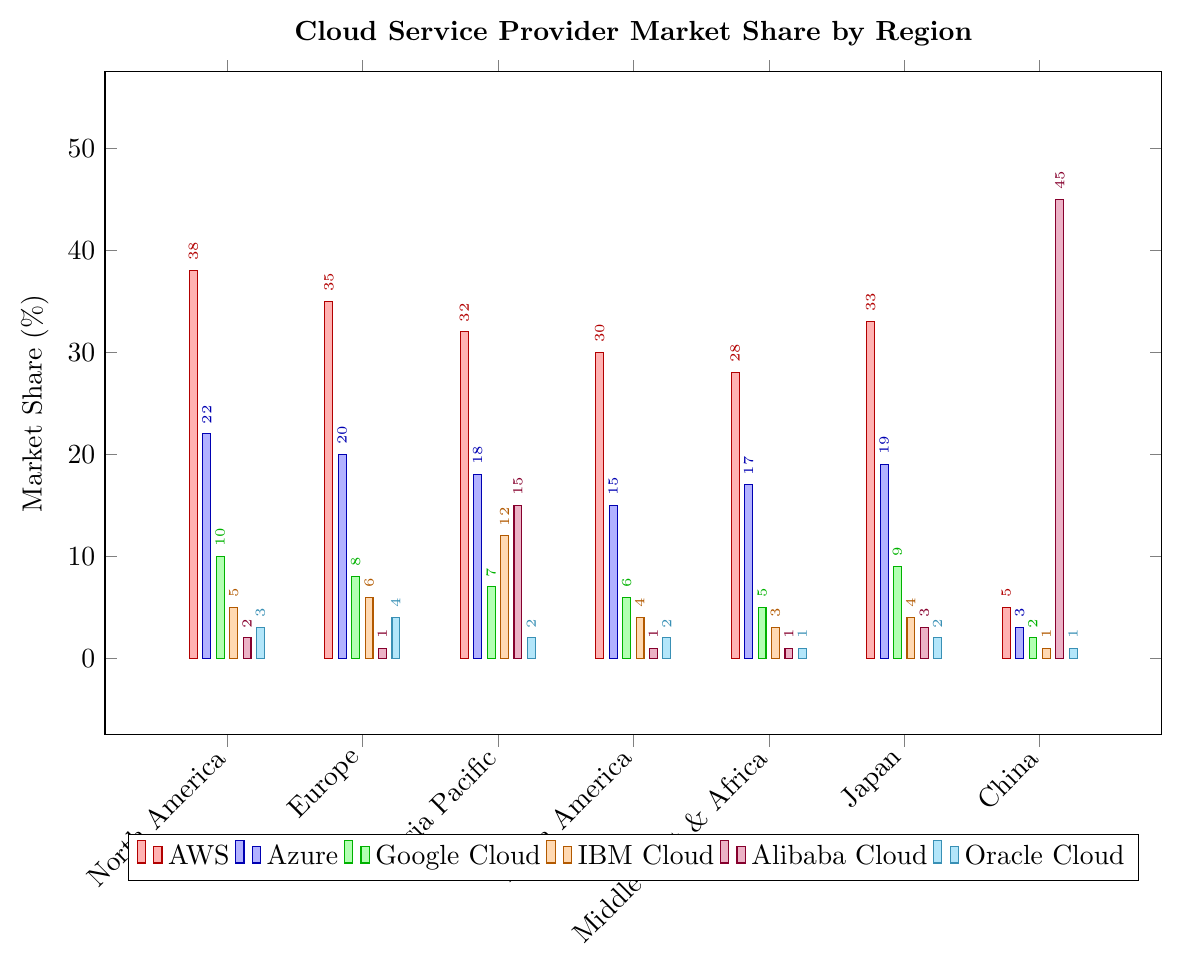Which region has the highest market share for AWS? To find the region with the highest market share for AWS, we observe the bar heights for AWS across all regions. North America has the tallest bar, representing 38%.
Answer: North America Which cloud provider has the largest market share in China? To determine the cloud provider with the largest market share in China, we look at the bars for each provider and find that Alibaba Cloud has the tallest bar at 45%.
Answer: Alibaba Cloud What is the total market share of AWS and Azure in Japan? We sum the market shares of AWS and Azure in Japan. AWS has 33% and Azure has 19%. Therefore, the total is 33 + 19 = 52%.
Answer: 52% Between Europe and Japan, which region has a higher market share for Google Cloud? Comparing Google Cloud shares visually, Europe has 8% and Japan has 9%. Thus, Japan has a higher share.
Answer: Japan What is the difference in market share for IBM Cloud between North America and Asia Pacific? Calculate the difference between North America's share (5%) and Asia Pacific's share (12%) for IBM Cloud, which is 12 - 5 = 7%.
Answer: 7% In which region does Oracle Cloud have the lowest market share? Observing the bar heights for Oracle Cloud, it's lowest in both China and Middle East & Africa at 1%.
Answer: China, Middle East & Africa Which three regions have the lowest market share for Azure? By comparing the heights of Azure's bars, the three regions with the lowest shares are China (3%), Latin America (15%), and Middle East & Africa (17%).
Answer: China, Latin America, Middle East & Africa What is the average market share of Alibaba Cloud across all regions except China? First, sum the shares of Alibaba Cloud in all regions except China: 2% (North America) + 1% (Europe) + 15% (Asia Pacific) + 1% (Latin America) + 1% (Middle East & Africa) + 3% (Japan) = 23%. Count of regions is 6. Therefore, the average is 23 / 6 ≈ 3.83%.
Answer: 3.83% Compare the market shares of Google Cloud and Oracle Cloud in the Asia Pacific region. Which one is higher? In the Asia Pacific region, Google Cloud has 7% and Oracle Cloud has 2%. Google Cloud's share is higher.
Answer: Google Cloud Which cloud provider has the smallest market share in the Middle East & Africa? Observing the bar lengths for Middle East & Africa, Oracle Cloud and Alibaba Cloud both have the smallest share at 1%.
Answer: Oracle Cloud, Alibaba Cloud 